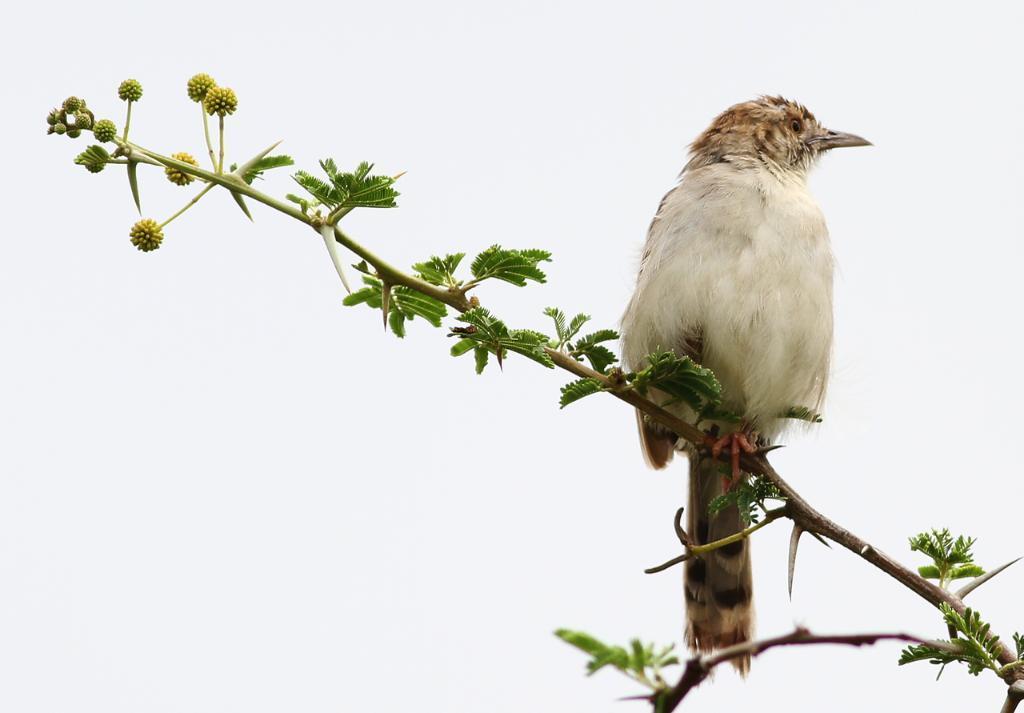In one or two sentences, can you explain what this image depicts? In this image we can see a bird on the plant stem and we can also see the white background. 